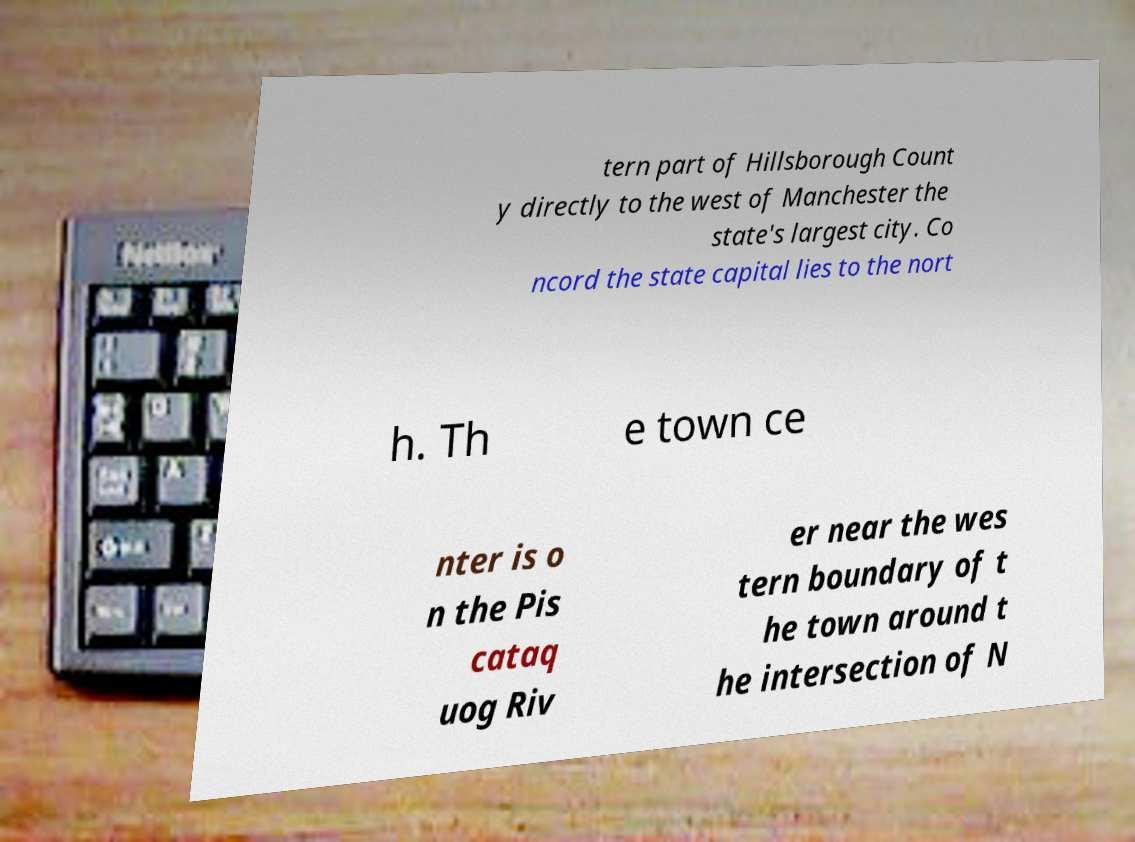Could you assist in decoding the text presented in this image and type it out clearly? tern part of Hillsborough Count y directly to the west of Manchester the state's largest city. Co ncord the state capital lies to the nort h. Th e town ce nter is o n the Pis cataq uog Riv er near the wes tern boundary of t he town around t he intersection of N 